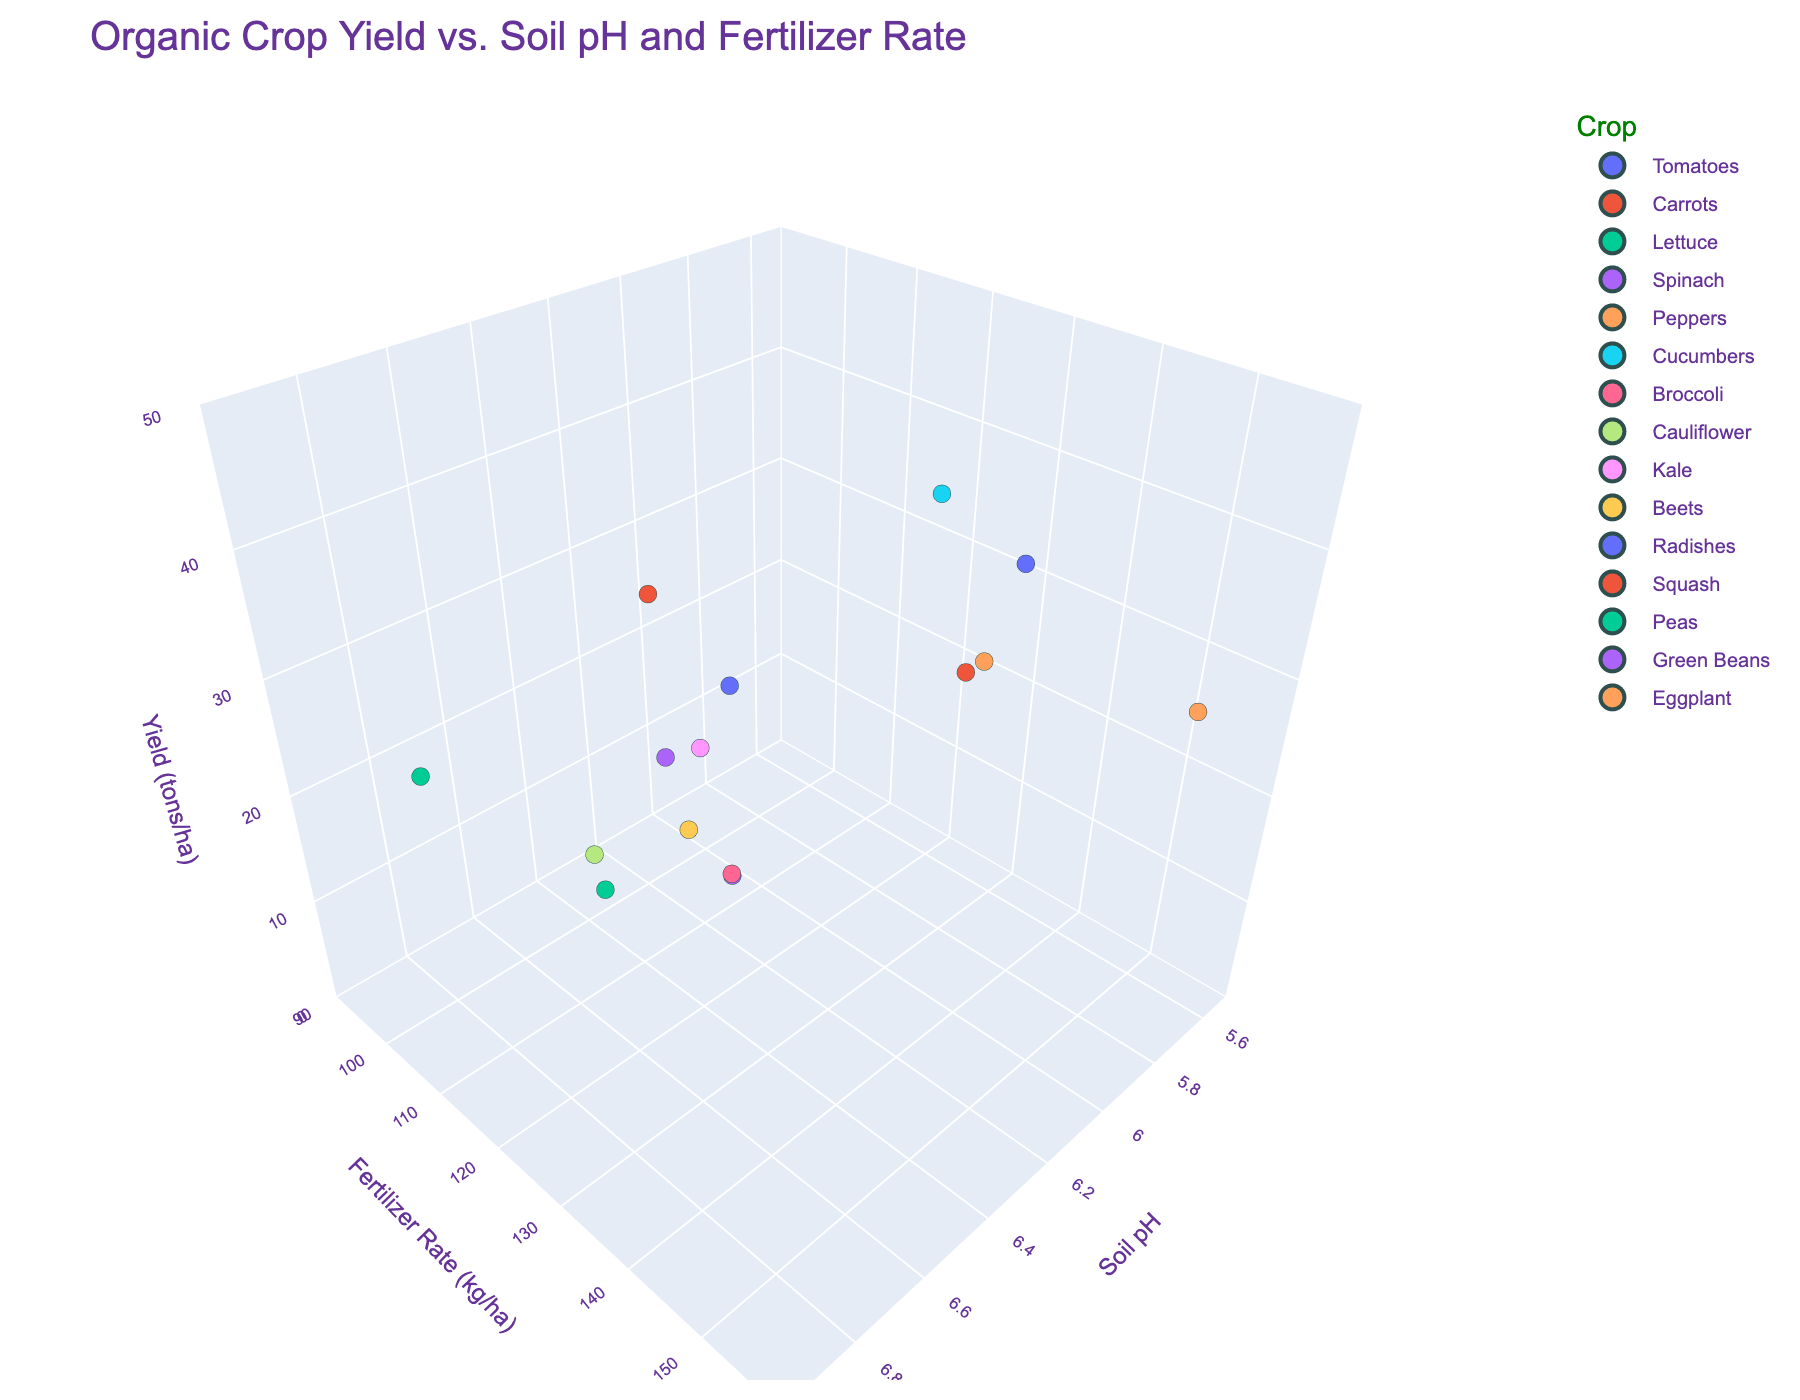What is the range of Soil pH values shown in the plot? The Soil pH axis ranges from 5.5 to 7.0 in the plot, as indicated by the axis labels and ticks.
Answer: 5.5 to 7.0 Which crop has the highest yield? The highest yield among the data points can be identified by locating the point with the highest value on the Yield (tons/ha) axis. This point corresponds to Tomatoes with a yield of 45.3 tons/ha.
Answer: Tomatoes How does the yield of Beets compare to that of Eggplant? To compare Beets and Eggplant, we look at their respective data points on the Yield (tons/ha) axis. Beets have a yield of 29.5 tons/ha, and Eggplant has a yield of 28.9 tons/ha. Beets have a slightly higher yield than Eggplant.
Answer: Beets are higher What is the relationship between Soil pH and Fertilizer Rate observed in the plot? The plot shows data points scattered with varying Soil pH and Fertilizer Rate values. There does not appear to be a clear linear relationship; points are scattered with no clear trend between Soil pH and Fertilizer Rate.
Answer: No clear relationship Which crop appears to have the lowest fertilizer application rate? The lowest value on the Fertilizer Rate (kg/ha) axis corresponds to Radishes, with a rate of 95 kg/ha.
Answer: Radishes What is the sum of the yields of the Kale and Broccoli plots? To find this, add the yields of Kale (14.6 tons/ha) and Broccoli (15.8 tons/ha). The sum is 14.6 + 15.8 = 30.4 tons/ha.
Answer: 30.4 tons/ha Determine the crop with the closest Soil pH value to 6.4. Examining the data points around Soil pH of 6.4, Broccoli is identified with a Soil pH of exactly 6.4.
Answer: Broccoli Which crop shows a balance between the given Soil pH and high fertilizer application rates? Inspecting data points with near-even values across both Soil pH and high Fertilizer Rates (above 140 kg/ha), Squash (Soil pH 6.2, Fertilizer Rate 145 kg/ha) seems balanced compared to others.
Answer: Squash 